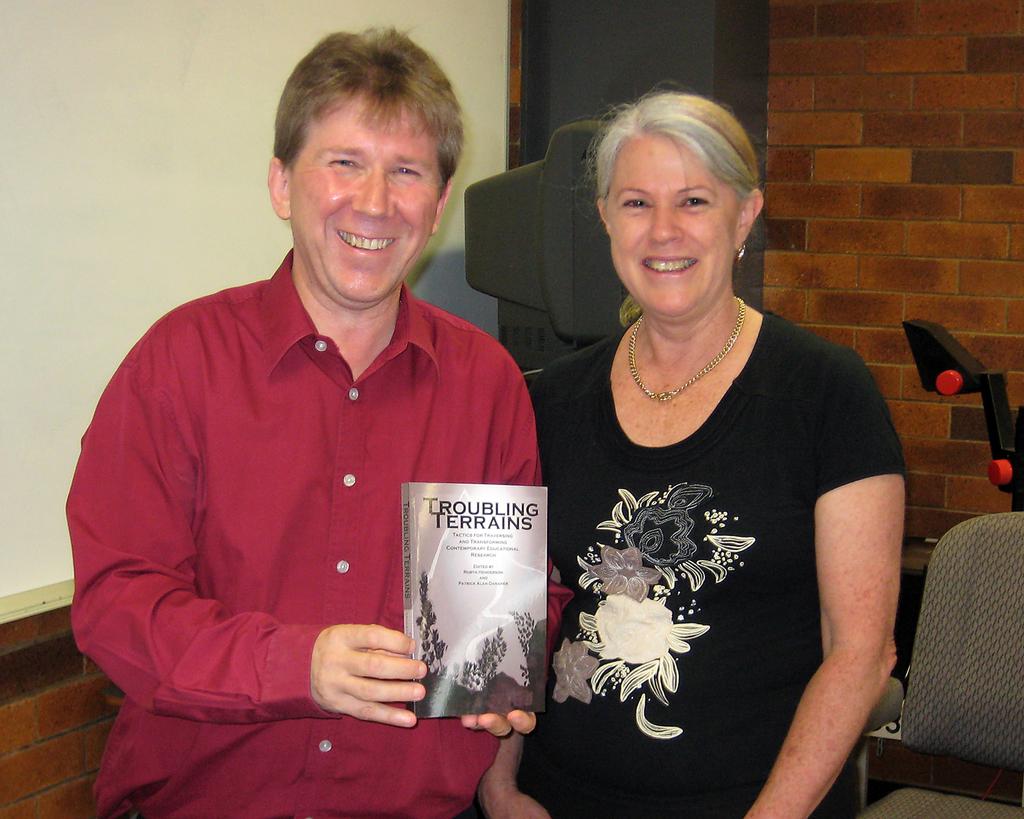What is the title of the book being held?
Offer a terse response. Troubling terrains. 